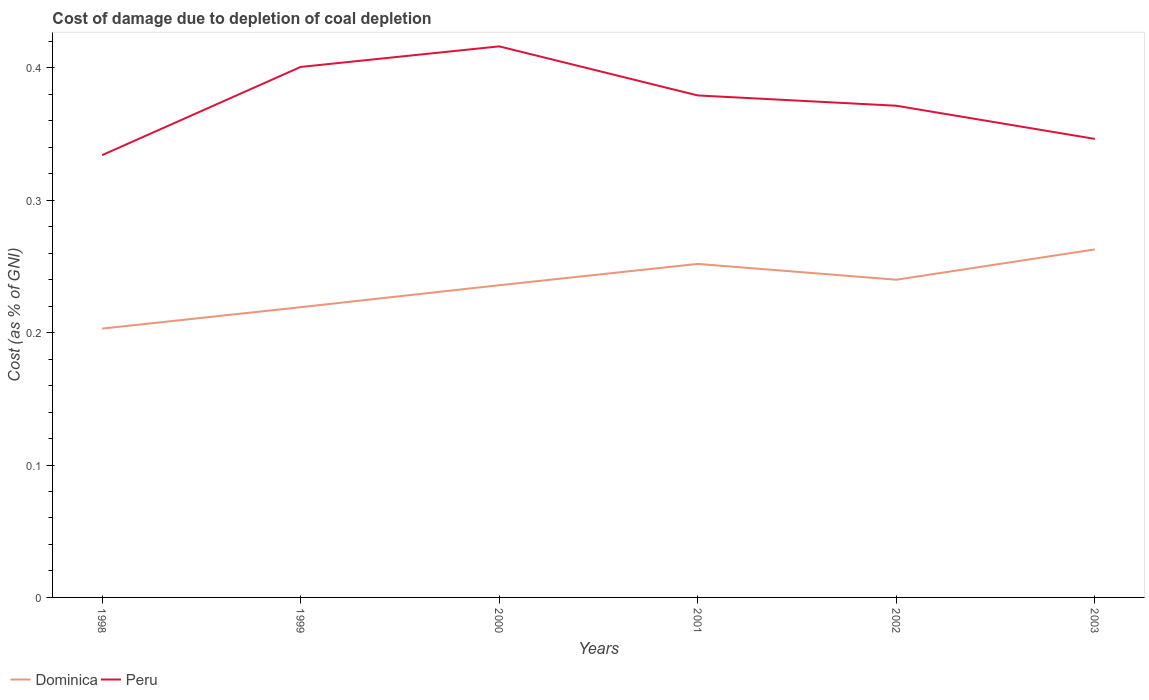How many different coloured lines are there?
Your answer should be compact. 2. Does the line corresponding to Peru intersect with the line corresponding to Dominica?
Offer a terse response. No. Across all years, what is the maximum cost of damage caused due to coal depletion in Peru?
Make the answer very short. 0.33. In which year was the cost of damage caused due to coal depletion in Dominica maximum?
Offer a terse response. 1998. What is the total cost of damage caused due to coal depletion in Peru in the graph?
Give a very brief answer. 0.03. What is the difference between the highest and the second highest cost of damage caused due to coal depletion in Peru?
Offer a very short reply. 0.08. What is the difference between the highest and the lowest cost of damage caused due to coal depletion in Dominica?
Your answer should be very brief. 4. Is the cost of damage caused due to coal depletion in Peru strictly greater than the cost of damage caused due to coal depletion in Dominica over the years?
Offer a terse response. No. How many lines are there?
Offer a terse response. 2. Are the values on the major ticks of Y-axis written in scientific E-notation?
Provide a short and direct response. No. Does the graph contain grids?
Ensure brevity in your answer.  No. What is the title of the graph?
Offer a terse response. Cost of damage due to depletion of coal depletion. What is the label or title of the X-axis?
Ensure brevity in your answer.  Years. What is the label or title of the Y-axis?
Offer a very short reply. Cost (as % of GNI). What is the Cost (as % of GNI) in Dominica in 1998?
Offer a very short reply. 0.2. What is the Cost (as % of GNI) of Peru in 1998?
Your answer should be very brief. 0.33. What is the Cost (as % of GNI) of Dominica in 1999?
Ensure brevity in your answer.  0.22. What is the Cost (as % of GNI) in Peru in 1999?
Your answer should be compact. 0.4. What is the Cost (as % of GNI) in Dominica in 2000?
Give a very brief answer. 0.24. What is the Cost (as % of GNI) in Peru in 2000?
Ensure brevity in your answer.  0.42. What is the Cost (as % of GNI) of Dominica in 2001?
Provide a short and direct response. 0.25. What is the Cost (as % of GNI) in Peru in 2001?
Ensure brevity in your answer.  0.38. What is the Cost (as % of GNI) in Dominica in 2002?
Ensure brevity in your answer.  0.24. What is the Cost (as % of GNI) of Peru in 2002?
Ensure brevity in your answer.  0.37. What is the Cost (as % of GNI) of Dominica in 2003?
Keep it short and to the point. 0.26. What is the Cost (as % of GNI) of Peru in 2003?
Offer a terse response. 0.35. Across all years, what is the maximum Cost (as % of GNI) of Dominica?
Give a very brief answer. 0.26. Across all years, what is the maximum Cost (as % of GNI) in Peru?
Keep it short and to the point. 0.42. Across all years, what is the minimum Cost (as % of GNI) of Dominica?
Offer a very short reply. 0.2. Across all years, what is the minimum Cost (as % of GNI) of Peru?
Keep it short and to the point. 0.33. What is the total Cost (as % of GNI) in Dominica in the graph?
Your answer should be compact. 1.41. What is the total Cost (as % of GNI) in Peru in the graph?
Make the answer very short. 2.25. What is the difference between the Cost (as % of GNI) of Dominica in 1998 and that in 1999?
Ensure brevity in your answer.  -0.02. What is the difference between the Cost (as % of GNI) in Peru in 1998 and that in 1999?
Your answer should be compact. -0.07. What is the difference between the Cost (as % of GNI) in Dominica in 1998 and that in 2000?
Provide a short and direct response. -0.03. What is the difference between the Cost (as % of GNI) in Peru in 1998 and that in 2000?
Ensure brevity in your answer.  -0.08. What is the difference between the Cost (as % of GNI) in Dominica in 1998 and that in 2001?
Give a very brief answer. -0.05. What is the difference between the Cost (as % of GNI) in Peru in 1998 and that in 2001?
Keep it short and to the point. -0.05. What is the difference between the Cost (as % of GNI) in Dominica in 1998 and that in 2002?
Give a very brief answer. -0.04. What is the difference between the Cost (as % of GNI) of Peru in 1998 and that in 2002?
Keep it short and to the point. -0.04. What is the difference between the Cost (as % of GNI) in Dominica in 1998 and that in 2003?
Keep it short and to the point. -0.06. What is the difference between the Cost (as % of GNI) in Peru in 1998 and that in 2003?
Make the answer very short. -0.01. What is the difference between the Cost (as % of GNI) of Dominica in 1999 and that in 2000?
Make the answer very short. -0.02. What is the difference between the Cost (as % of GNI) of Peru in 1999 and that in 2000?
Your answer should be compact. -0.02. What is the difference between the Cost (as % of GNI) in Dominica in 1999 and that in 2001?
Your answer should be compact. -0.03. What is the difference between the Cost (as % of GNI) of Peru in 1999 and that in 2001?
Keep it short and to the point. 0.02. What is the difference between the Cost (as % of GNI) of Dominica in 1999 and that in 2002?
Your response must be concise. -0.02. What is the difference between the Cost (as % of GNI) of Peru in 1999 and that in 2002?
Your answer should be very brief. 0.03. What is the difference between the Cost (as % of GNI) in Dominica in 1999 and that in 2003?
Provide a short and direct response. -0.04. What is the difference between the Cost (as % of GNI) in Peru in 1999 and that in 2003?
Provide a succinct answer. 0.05. What is the difference between the Cost (as % of GNI) of Dominica in 2000 and that in 2001?
Your answer should be very brief. -0.02. What is the difference between the Cost (as % of GNI) in Peru in 2000 and that in 2001?
Provide a succinct answer. 0.04. What is the difference between the Cost (as % of GNI) in Dominica in 2000 and that in 2002?
Provide a short and direct response. -0. What is the difference between the Cost (as % of GNI) in Peru in 2000 and that in 2002?
Make the answer very short. 0.04. What is the difference between the Cost (as % of GNI) in Dominica in 2000 and that in 2003?
Offer a very short reply. -0.03. What is the difference between the Cost (as % of GNI) in Peru in 2000 and that in 2003?
Your answer should be compact. 0.07. What is the difference between the Cost (as % of GNI) in Dominica in 2001 and that in 2002?
Keep it short and to the point. 0.01. What is the difference between the Cost (as % of GNI) of Peru in 2001 and that in 2002?
Your response must be concise. 0.01. What is the difference between the Cost (as % of GNI) of Dominica in 2001 and that in 2003?
Make the answer very short. -0.01. What is the difference between the Cost (as % of GNI) in Peru in 2001 and that in 2003?
Make the answer very short. 0.03. What is the difference between the Cost (as % of GNI) in Dominica in 2002 and that in 2003?
Give a very brief answer. -0.02. What is the difference between the Cost (as % of GNI) in Peru in 2002 and that in 2003?
Provide a succinct answer. 0.03. What is the difference between the Cost (as % of GNI) in Dominica in 1998 and the Cost (as % of GNI) in Peru in 1999?
Offer a very short reply. -0.2. What is the difference between the Cost (as % of GNI) in Dominica in 1998 and the Cost (as % of GNI) in Peru in 2000?
Your answer should be very brief. -0.21. What is the difference between the Cost (as % of GNI) in Dominica in 1998 and the Cost (as % of GNI) in Peru in 2001?
Offer a very short reply. -0.18. What is the difference between the Cost (as % of GNI) of Dominica in 1998 and the Cost (as % of GNI) of Peru in 2002?
Offer a very short reply. -0.17. What is the difference between the Cost (as % of GNI) of Dominica in 1998 and the Cost (as % of GNI) of Peru in 2003?
Provide a succinct answer. -0.14. What is the difference between the Cost (as % of GNI) of Dominica in 1999 and the Cost (as % of GNI) of Peru in 2000?
Provide a short and direct response. -0.2. What is the difference between the Cost (as % of GNI) of Dominica in 1999 and the Cost (as % of GNI) of Peru in 2001?
Provide a short and direct response. -0.16. What is the difference between the Cost (as % of GNI) in Dominica in 1999 and the Cost (as % of GNI) in Peru in 2002?
Keep it short and to the point. -0.15. What is the difference between the Cost (as % of GNI) of Dominica in 1999 and the Cost (as % of GNI) of Peru in 2003?
Ensure brevity in your answer.  -0.13. What is the difference between the Cost (as % of GNI) of Dominica in 2000 and the Cost (as % of GNI) of Peru in 2001?
Make the answer very short. -0.14. What is the difference between the Cost (as % of GNI) of Dominica in 2000 and the Cost (as % of GNI) of Peru in 2002?
Your response must be concise. -0.14. What is the difference between the Cost (as % of GNI) of Dominica in 2000 and the Cost (as % of GNI) of Peru in 2003?
Keep it short and to the point. -0.11. What is the difference between the Cost (as % of GNI) in Dominica in 2001 and the Cost (as % of GNI) in Peru in 2002?
Your answer should be compact. -0.12. What is the difference between the Cost (as % of GNI) in Dominica in 2001 and the Cost (as % of GNI) in Peru in 2003?
Offer a very short reply. -0.09. What is the difference between the Cost (as % of GNI) in Dominica in 2002 and the Cost (as % of GNI) in Peru in 2003?
Your answer should be compact. -0.11. What is the average Cost (as % of GNI) of Dominica per year?
Offer a very short reply. 0.24. What is the average Cost (as % of GNI) in Peru per year?
Offer a very short reply. 0.37. In the year 1998, what is the difference between the Cost (as % of GNI) of Dominica and Cost (as % of GNI) of Peru?
Your response must be concise. -0.13. In the year 1999, what is the difference between the Cost (as % of GNI) in Dominica and Cost (as % of GNI) in Peru?
Make the answer very short. -0.18. In the year 2000, what is the difference between the Cost (as % of GNI) in Dominica and Cost (as % of GNI) in Peru?
Offer a very short reply. -0.18. In the year 2001, what is the difference between the Cost (as % of GNI) of Dominica and Cost (as % of GNI) of Peru?
Your answer should be very brief. -0.13. In the year 2002, what is the difference between the Cost (as % of GNI) in Dominica and Cost (as % of GNI) in Peru?
Your answer should be compact. -0.13. In the year 2003, what is the difference between the Cost (as % of GNI) in Dominica and Cost (as % of GNI) in Peru?
Provide a succinct answer. -0.08. What is the ratio of the Cost (as % of GNI) in Dominica in 1998 to that in 1999?
Provide a short and direct response. 0.93. What is the ratio of the Cost (as % of GNI) of Peru in 1998 to that in 1999?
Provide a short and direct response. 0.83. What is the ratio of the Cost (as % of GNI) of Dominica in 1998 to that in 2000?
Offer a very short reply. 0.86. What is the ratio of the Cost (as % of GNI) of Peru in 1998 to that in 2000?
Keep it short and to the point. 0.8. What is the ratio of the Cost (as % of GNI) in Dominica in 1998 to that in 2001?
Ensure brevity in your answer.  0.81. What is the ratio of the Cost (as % of GNI) of Peru in 1998 to that in 2001?
Offer a terse response. 0.88. What is the ratio of the Cost (as % of GNI) in Dominica in 1998 to that in 2002?
Provide a succinct answer. 0.85. What is the ratio of the Cost (as % of GNI) in Peru in 1998 to that in 2002?
Provide a short and direct response. 0.9. What is the ratio of the Cost (as % of GNI) in Dominica in 1998 to that in 2003?
Provide a succinct answer. 0.77. What is the ratio of the Cost (as % of GNI) in Peru in 1998 to that in 2003?
Offer a very short reply. 0.96. What is the ratio of the Cost (as % of GNI) of Dominica in 1999 to that in 2000?
Give a very brief answer. 0.93. What is the ratio of the Cost (as % of GNI) of Peru in 1999 to that in 2000?
Your response must be concise. 0.96. What is the ratio of the Cost (as % of GNI) in Dominica in 1999 to that in 2001?
Keep it short and to the point. 0.87. What is the ratio of the Cost (as % of GNI) of Peru in 1999 to that in 2001?
Ensure brevity in your answer.  1.06. What is the ratio of the Cost (as % of GNI) in Dominica in 1999 to that in 2002?
Offer a very short reply. 0.91. What is the ratio of the Cost (as % of GNI) in Peru in 1999 to that in 2002?
Give a very brief answer. 1.08. What is the ratio of the Cost (as % of GNI) in Dominica in 1999 to that in 2003?
Offer a terse response. 0.83. What is the ratio of the Cost (as % of GNI) of Peru in 1999 to that in 2003?
Provide a short and direct response. 1.16. What is the ratio of the Cost (as % of GNI) of Dominica in 2000 to that in 2001?
Offer a terse response. 0.94. What is the ratio of the Cost (as % of GNI) of Peru in 2000 to that in 2001?
Your answer should be compact. 1.1. What is the ratio of the Cost (as % of GNI) in Dominica in 2000 to that in 2002?
Your answer should be very brief. 0.98. What is the ratio of the Cost (as % of GNI) in Peru in 2000 to that in 2002?
Your response must be concise. 1.12. What is the ratio of the Cost (as % of GNI) of Dominica in 2000 to that in 2003?
Your answer should be very brief. 0.9. What is the ratio of the Cost (as % of GNI) in Peru in 2000 to that in 2003?
Your answer should be compact. 1.2. What is the ratio of the Cost (as % of GNI) in Dominica in 2001 to that in 2002?
Provide a succinct answer. 1.05. What is the ratio of the Cost (as % of GNI) of Peru in 2001 to that in 2002?
Give a very brief answer. 1.02. What is the ratio of the Cost (as % of GNI) of Peru in 2001 to that in 2003?
Offer a very short reply. 1.09. What is the ratio of the Cost (as % of GNI) of Dominica in 2002 to that in 2003?
Provide a short and direct response. 0.91. What is the ratio of the Cost (as % of GNI) in Peru in 2002 to that in 2003?
Offer a terse response. 1.07. What is the difference between the highest and the second highest Cost (as % of GNI) of Dominica?
Keep it short and to the point. 0.01. What is the difference between the highest and the second highest Cost (as % of GNI) in Peru?
Your answer should be compact. 0.02. What is the difference between the highest and the lowest Cost (as % of GNI) in Dominica?
Keep it short and to the point. 0.06. What is the difference between the highest and the lowest Cost (as % of GNI) in Peru?
Make the answer very short. 0.08. 